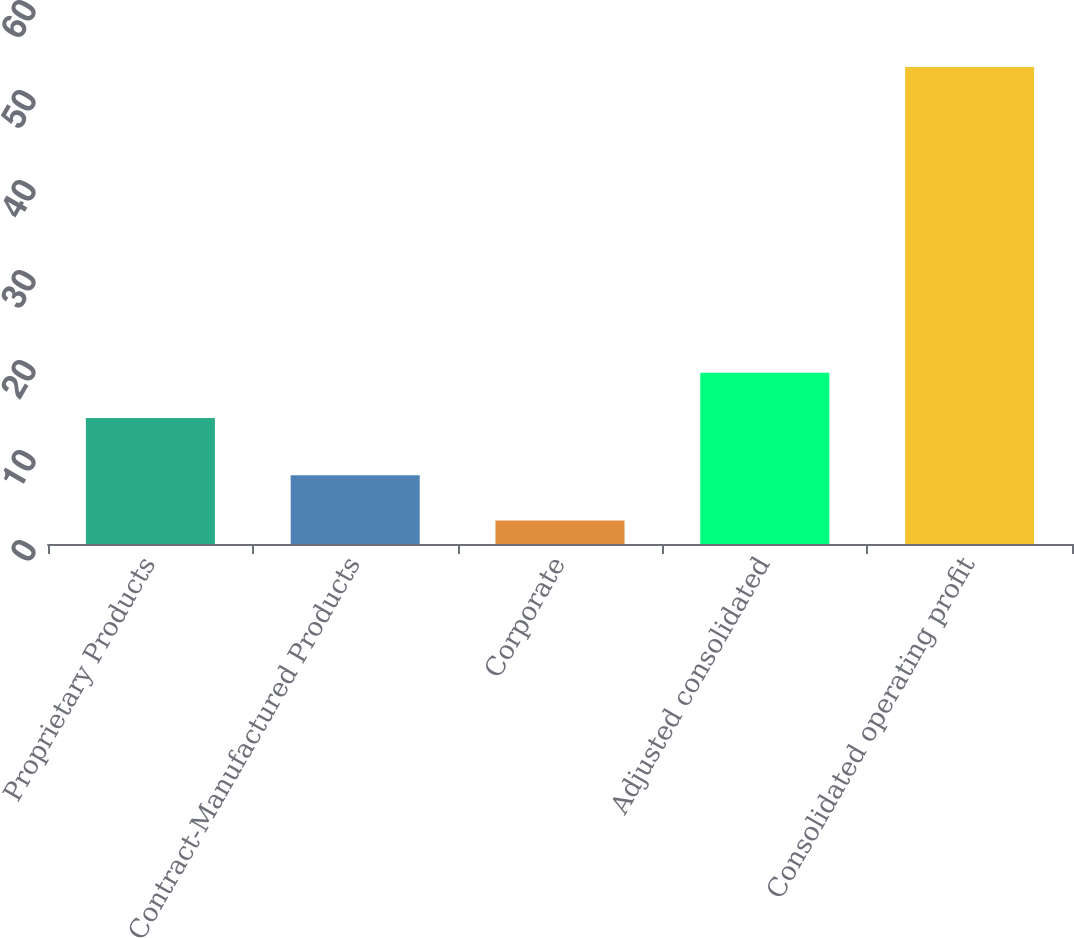<chart> <loc_0><loc_0><loc_500><loc_500><bar_chart><fcel>Proprietary Products<fcel>Contract-Manufactured Products<fcel>Corporate<fcel>Adjusted consolidated<fcel>Consolidated operating profit<nl><fcel>14<fcel>7.64<fcel>2.6<fcel>19.04<fcel>53<nl></chart> 